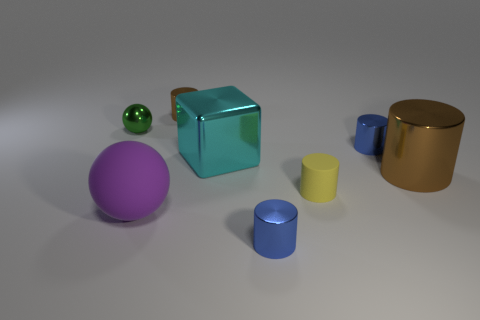Subtract all large brown cylinders. How many cylinders are left? 4 Subtract all yellow cylinders. How many cylinders are left? 4 Subtract all purple cylinders. Subtract all blue spheres. How many cylinders are left? 5 Add 1 tiny cyan cubes. How many objects exist? 9 Subtract all cubes. How many objects are left? 7 Subtract all big green metal things. Subtract all small metal cylinders. How many objects are left? 5 Add 3 shiny blocks. How many shiny blocks are left? 4 Add 7 big blocks. How many big blocks exist? 8 Subtract 0 red spheres. How many objects are left? 8 